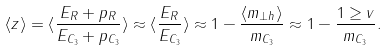<formula> <loc_0><loc_0><loc_500><loc_500>\langle z \rangle = \langle \frac { E _ { R } + p _ { \| R } } { E _ { C _ { 3 } } + p _ { \| C _ { 3 } } } \rangle \approx \langle \frac { E _ { R } } { E _ { C _ { 3 } } } \rangle \approx 1 - \frac { \langle m _ { \perp h } \rangle } { m _ { C _ { 3 } } } \approx 1 - \frac { 1 \geq v } { m _ { C _ { 3 } } } .</formula> 